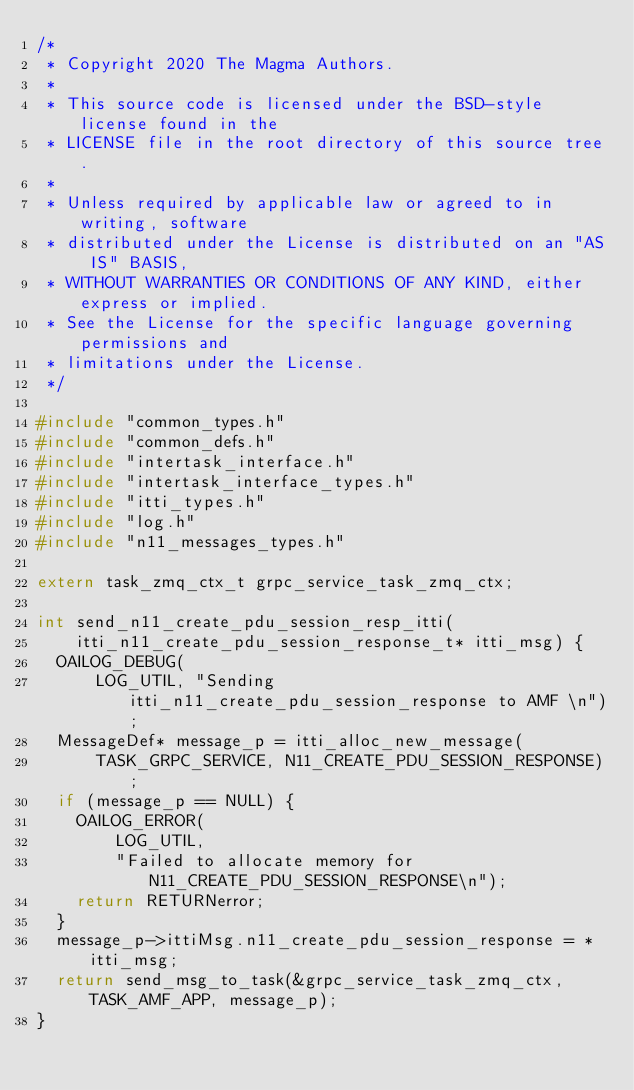Convert code to text. <code><loc_0><loc_0><loc_500><loc_500><_C_>/*
 * Copyright 2020 The Magma Authors.
 *
 * This source code is licensed under the BSD-style license found in the
 * LICENSE file in the root directory of this source tree.
 *
 * Unless required by applicable law or agreed to in writing, software
 * distributed under the License is distributed on an "AS IS" BASIS,
 * WITHOUT WARRANTIES OR CONDITIONS OF ANY KIND, either express or implied.
 * See the License for the specific language governing permissions and
 * limitations under the License.
 */

#include "common_types.h"
#include "common_defs.h"
#include "intertask_interface.h"
#include "intertask_interface_types.h"
#include "itti_types.h"
#include "log.h"
#include "n11_messages_types.h"

extern task_zmq_ctx_t grpc_service_task_zmq_ctx;

int send_n11_create_pdu_session_resp_itti(
    itti_n11_create_pdu_session_response_t* itti_msg) {
  OAILOG_DEBUG(
      LOG_UTIL, "Sending itti_n11_create_pdu_session_response to AMF \n");
  MessageDef* message_p = itti_alloc_new_message(
      TASK_GRPC_SERVICE, N11_CREATE_PDU_SESSION_RESPONSE);
  if (message_p == NULL) {
    OAILOG_ERROR(
        LOG_UTIL,
        "Failed to allocate memory for N11_CREATE_PDU_SESSION_RESPONSE\n");
    return RETURNerror;
  }
  message_p->ittiMsg.n11_create_pdu_session_response = *itti_msg;
  return send_msg_to_task(&grpc_service_task_zmq_ctx, TASK_AMF_APP, message_p);
}
</code> 